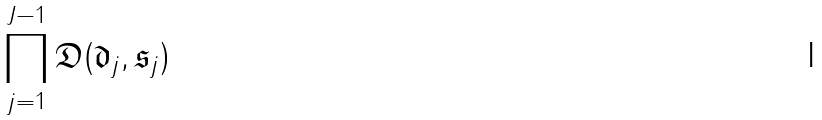Convert formula to latex. <formula><loc_0><loc_0><loc_500><loc_500>\prod _ { j = 1 } ^ { J - 1 } \mathfrak { D } ( \mathfrak { d } _ { j } , \mathfrak { s } _ { j } )</formula> 